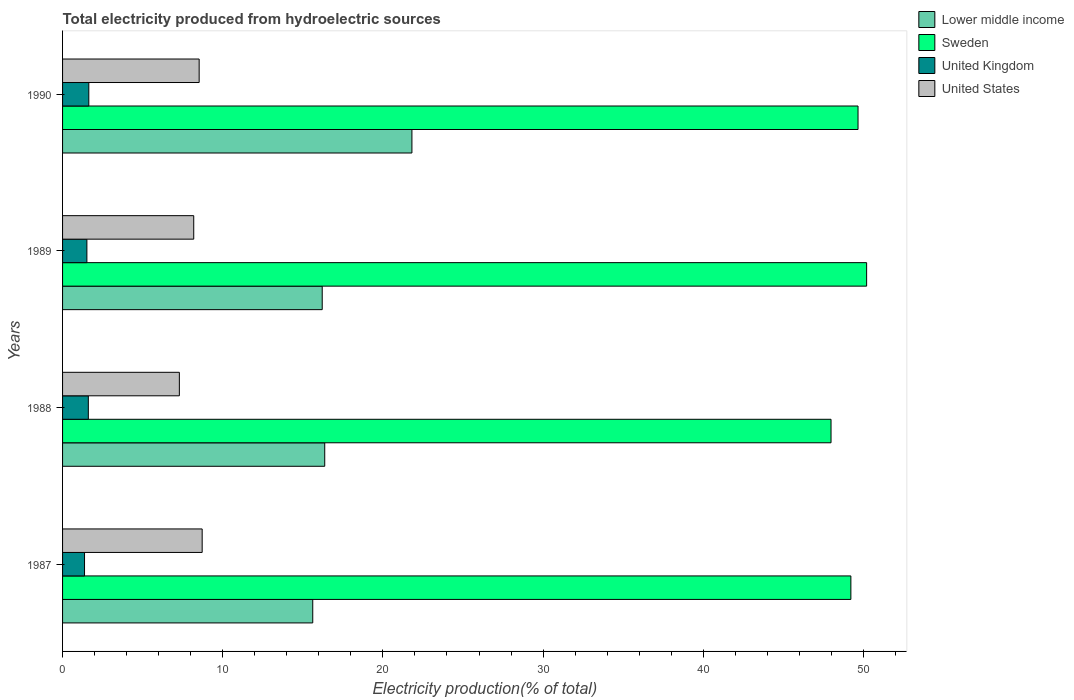How many different coloured bars are there?
Offer a terse response. 4. How many groups of bars are there?
Your answer should be compact. 4. How many bars are there on the 1st tick from the top?
Provide a short and direct response. 4. How many bars are there on the 1st tick from the bottom?
Ensure brevity in your answer.  4. What is the total electricity produced in United Kingdom in 1987?
Ensure brevity in your answer.  1.37. Across all years, what is the maximum total electricity produced in Lower middle income?
Your answer should be very brief. 21.81. Across all years, what is the minimum total electricity produced in United States?
Your response must be concise. 7.29. What is the total total electricity produced in Lower middle income in the graph?
Give a very brief answer. 70.01. What is the difference between the total electricity produced in United Kingdom in 1987 and that in 1990?
Provide a succinct answer. -0.27. What is the difference between the total electricity produced in Sweden in 1987 and the total electricity produced in Lower middle income in 1988?
Your response must be concise. 32.85. What is the average total electricity produced in United States per year?
Your answer should be very brief. 8.18. In the year 1989, what is the difference between the total electricity produced in United Kingdom and total electricity produced in Sweden?
Provide a succinct answer. -48.68. In how many years, is the total electricity produced in United Kingdom greater than 44 %?
Keep it short and to the point. 0. What is the ratio of the total electricity produced in Sweden in 1987 to that in 1989?
Your answer should be compact. 0.98. Is the difference between the total electricity produced in United Kingdom in 1987 and 1989 greater than the difference between the total electricity produced in Sweden in 1987 and 1989?
Offer a very short reply. Yes. What is the difference between the highest and the second highest total electricity produced in Sweden?
Keep it short and to the point. 0.54. What is the difference between the highest and the lowest total electricity produced in United Kingdom?
Your answer should be very brief. 0.27. In how many years, is the total electricity produced in Sweden greater than the average total electricity produced in Sweden taken over all years?
Keep it short and to the point. 2. Is the sum of the total electricity produced in United States in 1987 and 1989 greater than the maximum total electricity produced in Lower middle income across all years?
Your answer should be compact. No. Is it the case that in every year, the sum of the total electricity produced in Sweden and total electricity produced in United States is greater than the sum of total electricity produced in United Kingdom and total electricity produced in Lower middle income?
Provide a short and direct response. No. Is it the case that in every year, the sum of the total electricity produced in United Kingdom and total electricity produced in United States is greater than the total electricity produced in Lower middle income?
Ensure brevity in your answer.  No. How many bars are there?
Your answer should be very brief. 16. Are all the bars in the graph horizontal?
Offer a very short reply. Yes. What is the difference between two consecutive major ticks on the X-axis?
Offer a very short reply. 10. Does the graph contain any zero values?
Offer a very short reply. No. Does the graph contain grids?
Ensure brevity in your answer.  No. Where does the legend appear in the graph?
Your answer should be compact. Top right. What is the title of the graph?
Your answer should be very brief. Total electricity produced from hydroelectric sources. What is the label or title of the X-axis?
Make the answer very short. Electricity production(% of total). What is the Electricity production(% of total) in Lower middle income in 1987?
Ensure brevity in your answer.  15.62. What is the Electricity production(% of total) in Sweden in 1987?
Your answer should be very brief. 49.22. What is the Electricity production(% of total) of United Kingdom in 1987?
Offer a terse response. 1.37. What is the Electricity production(% of total) of United States in 1987?
Ensure brevity in your answer.  8.72. What is the Electricity production(% of total) in Lower middle income in 1988?
Provide a succinct answer. 16.37. What is the Electricity production(% of total) of Sweden in 1988?
Your response must be concise. 47.98. What is the Electricity production(% of total) in United Kingdom in 1988?
Ensure brevity in your answer.  1.61. What is the Electricity production(% of total) in United States in 1988?
Offer a very short reply. 7.29. What is the Electricity production(% of total) in Lower middle income in 1989?
Your answer should be compact. 16.21. What is the Electricity production(% of total) in Sweden in 1989?
Offer a very short reply. 50.2. What is the Electricity production(% of total) in United Kingdom in 1989?
Ensure brevity in your answer.  1.52. What is the Electricity production(% of total) of United States in 1989?
Offer a very short reply. 8.19. What is the Electricity production(% of total) of Lower middle income in 1990?
Your answer should be compact. 21.81. What is the Electricity production(% of total) of Sweden in 1990?
Keep it short and to the point. 49.67. What is the Electricity production(% of total) of United Kingdom in 1990?
Ensure brevity in your answer.  1.64. What is the Electricity production(% of total) of United States in 1990?
Your response must be concise. 8.53. Across all years, what is the maximum Electricity production(% of total) of Lower middle income?
Give a very brief answer. 21.81. Across all years, what is the maximum Electricity production(% of total) in Sweden?
Give a very brief answer. 50.2. Across all years, what is the maximum Electricity production(% of total) in United Kingdom?
Offer a terse response. 1.64. Across all years, what is the maximum Electricity production(% of total) in United States?
Provide a succinct answer. 8.72. Across all years, what is the minimum Electricity production(% of total) of Lower middle income?
Provide a succinct answer. 15.62. Across all years, what is the minimum Electricity production(% of total) in Sweden?
Provide a short and direct response. 47.98. Across all years, what is the minimum Electricity production(% of total) in United Kingdom?
Offer a very short reply. 1.37. Across all years, what is the minimum Electricity production(% of total) of United States?
Keep it short and to the point. 7.29. What is the total Electricity production(% of total) of Lower middle income in the graph?
Offer a very short reply. 70.01. What is the total Electricity production(% of total) in Sweden in the graph?
Make the answer very short. 197.06. What is the total Electricity production(% of total) of United Kingdom in the graph?
Offer a terse response. 6.14. What is the total Electricity production(% of total) of United States in the graph?
Give a very brief answer. 32.73. What is the difference between the Electricity production(% of total) of Lower middle income in 1987 and that in 1988?
Your answer should be compact. -0.75. What is the difference between the Electricity production(% of total) of Sweden in 1987 and that in 1988?
Offer a very short reply. 1.24. What is the difference between the Electricity production(% of total) of United Kingdom in 1987 and that in 1988?
Your response must be concise. -0.24. What is the difference between the Electricity production(% of total) of United States in 1987 and that in 1988?
Offer a very short reply. 1.42. What is the difference between the Electricity production(% of total) in Lower middle income in 1987 and that in 1989?
Give a very brief answer. -0.59. What is the difference between the Electricity production(% of total) of Sweden in 1987 and that in 1989?
Offer a very short reply. -0.98. What is the difference between the Electricity production(% of total) in United Kingdom in 1987 and that in 1989?
Ensure brevity in your answer.  -0.15. What is the difference between the Electricity production(% of total) in United States in 1987 and that in 1989?
Offer a terse response. 0.53. What is the difference between the Electricity production(% of total) of Lower middle income in 1987 and that in 1990?
Ensure brevity in your answer.  -6.19. What is the difference between the Electricity production(% of total) in Sweden in 1987 and that in 1990?
Your answer should be very brief. -0.45. What is the difference between the Electricity production(% of total) of United Kingdom in 1987 and that in 1990?
Your answer should be compact. -0.27. What is the difference between the Electricity production(% of total) of United States in 1987 and that in 1990?
Ensure brevity in your answer.  0.19. What is the difference between the Electricity production(% of total) in Lower middle income in 1988 and that in 1989?
Keep it short and to the point. 0.16. What is the difference between the Electricity production(% of total) in Sweden in 1988 and that in 1989?
Provide a succinct answer. -2.22. What is the difference between the Electricity production(% of total) in United Kingdom in 1988 and that in 1989?
Offer a terse response. 0.09. What is the difference between the Electricity production(% of total) of United States in 1988 and that in 1989?
Ensure brevity in your answer.  -0.9. What is the difference between the Electricity production(% of total) of Lower middle income in 1988 and that in 1990?
Keep it short and to the point. -5.44. What is the difference between the Electricity production(% of total) in Sweden in 1988 and that in 1990?
Offer a terse response. -1.69. What is the difference between the Electricity production(% of total) of United Kingdom in 1988 and that in 1990?
Make the answer very short. -0.03. What is the difference between the Electricity production(% of total) of United States in 1988 and that in 1990?
Offer a very short reply. -1.24. What is the difference between the Electricity production(% of total) in Lower middle income in 1989 and that in 1990?
Offer a terse response. -5.6. What is the difference between the Electricity production(% of total) in Sweden in 1989 and that in 1990?
Offer a terse response. 0.54. What is the difference between the Electricity production(% of total) in United Kingdom in 1989 and that in 1990?
Offer a very short reply. -0.12. What is the difference between the Electricity production(% of total) in United States in 1989 and that in 1990?
Your answer should be compact. -0.34. What is the difference between the Electricity production(% of total) in Lower middle income in 1987 and the Electricity production(% of total) in Sweden in 1988?
Offer a terse response. -32.36. What is the difference between the Electricity production(% of total) of Lower middle income in 1987 and the Electricity production(% of total) of United Kingdom in 1988?
Your answer should be compact. 14.01. What is the difference between the Electricity production(% of total) in Lower middle income in 1987 and the Electricity production(% of total) in United States in 1988?
Provide a succinct answer. 8.33. What is the difference between the Electricity production(% of total) in Sweden in 1987 and the Electricity production(% of total) in United Kingdom in 1988?
Keep it short and to the point. 47.61. What is the difference between the Electricity production(% of total) in Sweden in 1987 and the Electricity production(% of total) in United States in 1988?
Make the answer very short. 41.93. What is the difference between the Electricity production(% of total) in United Kingdom in 1987 and the Electricity production(% of total) in United States in 1988?
Give a very brief answer. -5.92. What is the difference between the Electricity production(% of total) in Lower middle income in 1987 and the Electricity production(% of total) in Sweden in 1989?
Make the answer very short. -34.58. What is the difference between the Electricity production(% of total) of Lower middle income in 1987 and the Electricity production(% of total) of United Kingdom in 1989?
Offer a very short reply. 14.1. What is the difference between the Electricity production(% of total) in Lower middle income in 1987 and the Electricity production(% of total) in United States in 1989?
Ensure brevity in your answer.  7.43. What is the difference between the Electricity production(% of total) in Sweden in 1987 and the Electricity production(% of total) in United Kingdom in 1989?
Offer a very short reply. 47.7. What is the difference between the Electricity production(% of total) in Sweden in 1987 and the Electricity production(% of total) in United States in 1989?
Keep it short and to the point. 41.03. What is the difference between the Electricity production(% of total) in United Kingdom in 1987 and the Electricity production(% of total) in United States in 1989?
Your answer should be compact. -6.82. What is the difference between the Electricity production(% of total) of Lower middle income in 1987 and the Electricity production(% of total) of Sweden in 1990?
Your response must be concise. -34.05. What is the difference between the Electricity production(% of total) of Lower middle income in 1987 and the Electricity production(% of total) of United Kingdom in 1990?
Give a very brief answer. 13.98. What is the difference between the Electricity production(% of total) in Lower middle income in 1987 and the Electricity production(% of total) in United States in 1990?
Your response must be concise. 7.09. What is the difference between the Electricity production(% of total) of Sweden in 1987 and the Electricity production(% of total) of United Kingdom in 1990?
Your answer should be compact. 47.58. What is the difference between the Electricity production(% of total) in Sweden in 1987 and the Electricity production(% of total) in United States in 1990?
Your answer should be compact. 40.69. What is the difference between the Electricity production(% of total) of United Kingdom in 1987 and the Electricity production(% of total) of United States in 1990?
Provide a short and direct response. -7.16. What is the difference between the Electricity production(% of total) in Lower middle income in 1988 and the Electricity production(% of total) in Sweden in 1989?
Your response must be concise. -33.83. What is the difference between the Electricity production(% of total) of Lower middle income in 1988 and the Electricity production(% of total) of United Kingdom in 1989?
Keep it short and to the point. 14.85. What is the difference between the Electricity production(% of total) in Lower middle income in 1988 and the Electricity production(% of total) in United States in 1989?
Offer a very short reply. 8.18. What is the difference between the Electricity production(% of total) in Sweden in 1988 and the Electricity production(% of total) in United Kingdom in 1989?
Keep it short and to the point. 46.46. What is the difference between the Electricity production(% of total) in Sweden in 1988 and the Electricity production(% of total) in United States in 1989?
Your answer should be very brief. 39.79. What is the difference between the Electricity production(% of total) in United Kingdom in 1988 and the Electricity production(% of total) in United States in 1989?
Offer a terse response. -6.58. What is the difference between the Electricity production(% of total) in Lower middle income in 1988 and the Electricity production(% of total) in Sweden in 1990?
Your response must be concise. -33.3. What is the difference between the Electricity production(% of total) in Lower middle income in 1988 and the Electricity production(% of total) in United Kingdom in 1990?
Provide a succinct answer. 14.73. What is the difference between the Electricity production(% of total) in Lower middle income in 1988 and the Electricity production(% of total) in United States in 1990?
Ensure brevity in your answer.  7.84. What is the difference between the Electricity production(% of total) in Sweden in 1988 and the Electricity production(% of total) in United Kingdom in 1990?
Your answer should be very brief. 46.34. What is the difference between the Electricity production(% of total) of Sweden in 1988 and the Electricity production(% of total) of United States in 1990?
Your answer should be very brief. 39.45. What is the difference between the Electricity production(% of total) of United Kingdom in 1988 and the Electricity production(% of total) of United States in 1990?
Your answer should be very brief. -6.92. What is the difference between the Electricity production(% of total) in Lower middle income in 1989 and the Electricity production(% of total) in Sweden in 1990?
Provide a short and direct response. -33.45. What is the difference between the Electricity production(% of total) in Lower middle income in 1989 and the Electricity production(% of total) in United Kingdom in 1990?
Make the answer very short. 14.57. What is the difference between the Electricity production(% of total) of Lower middle income in 1989 and the Electricity production(% of total) of United States in 1990?
Provide a succinct answer. 7.68. What is the difference between the Electricity production(% of total) of Sweden in 1989 and the Electricity production(% of total) of United Kingdom in 1990?
Your response must be concise. 48.56. What is the difference between the Electricity production(% of total) of Sweden in 1989 and the Electricity production(% of total) of United States in 1990?
Offer a very short reply. 41.67. What is the difference between the Electricity production(% of total) in United Kingdom in 1989 and the Electricity production(% of total) in United States in 1990?
Offer a terse response. -7.01. What is the average Electricity production(% of total) of Lower middle income per year?
Make the answer very short. 17.5. What is the average Electricity production(% of total) of Sweden per year?
Ensure brevity in your answer.  49.27. What is the average Electricity production(% of total) of United Kingdom per year?
Keep it short and to the point. 1.53. What is the average Electricity production(% of total) in United States per year?
Your answer should be compact. 8.18. In the year 1987, what is the difference between the Electricity production(% of total) in Lower middle income and Electricity production(% of total) in Sweden?
Offer a terse response. -33.6. In the year 1987, what is the difference between the Electricity production(% of total) of Lower middle income and Electricity production(% of total) of United Kingdom?
Provide a short and direct response. 14.25. In the year 1987, what is the difference between the Electricity production(% of total) of Lower middle income and Electricity production(% of total) of United States?
Offer a terse response. 6.9. In the year 1987, what is the difference between the Electricity production(% of total) in Sweden and Electricity production(% of total) in United Kingdom?
Your answer should be very brief. 47.85. In the year 1987, what is the difference between the Electricity production(% of total) in Sweden and Electricity production(% of total) in United States?
Make the answer very short. 40.5. In the year 1987, what is the difference between the Electricity production(% of total) of United Kingdom and Electricity production(% of total) of United States?
Keep it short and to the point. -7.35. In the year 1988, what is the difference between the Electricity production(% of total) of Lower middle income and Electricity production(% of total) of Sweden?
Your response must be concise. -31.61. In the year 1988, what is the difference between the Electricity production(% of total) in Lower middle income and Electricity production(% of total) in United Kingdom?
Make the answer very short. 14.76. In the year 1988, what is the difference between the Electricity production(% of total) in Lower middle income and Electricity production(% of total) in United States?
Ensure brevity in your answer.  9.08. In the year 1988, what is the difference between the Electricity production(% of total) of Sweden and Electricity production(% of total) of United Kingdom?
Your answer should be very brief. 46.37. In the year 1988, what is the difference between the Electricity production(% of total) of Sweden and Electricity production(% of total) of United States?
Provide a succinct answer. 40.69. In the year 1988, what is the difference between the Electricity production(% of total) of United Kingdom and Electricity production(% of total) of United States?
Give a very brief answer. -5.68. In the year 1989, what is the difference between the Electricity production(% of total) of Lower middle income and Electricity production(% of total) of Sweden?
Provide a succinct answer. -33.99. In the year 1989, what is the difference between the Electricity production(% of total) of Lower middle income and Electricity production(% of total) of United Kingdom?
Your response must be concise. 14.69. In the year 1989, what is the difference between the Electricity production(% of total) in Lower middle income and Electricity production(% of total) in United States?
Make the answer very short. 8.02. In the year 1989, what is the difference between the Electricity production(% of total) of Sweden and Electricity production(% of total) of United Kingdom?
Provide a succinct answer. 48.68. In the year 1989, what is the difference between the Electricity production(% of total) in Sweden and Electricity production(% of total) in United States?
Offer a terse response. 42.01. In the year 1989, what is the difference between the Electricity production(% of total) in United Kingdom and Electricity production(% of total) in United States?
Ensure brevity in your answer.  -6.67. In the year 1990, what is the difference between the Electricity production(% of total) of Lower middle income and Electricity production(% of total) of Sweden?
Provide a short and direct response. -27.85. In the year 1990, what is the difference between the Electricity production(% of total) of Lower middle income and Electricity production(% of total) of United Kingdom?
Your answer should be very brief. 20.17. In the year 1990, what is the difference between the Electricity production(% of total) in Lower middle income and Electricity production(% of total) in United States?
Provide a succinct answer. 13.28. In the year 1990, what is the difference between the Electricity production(% of total) of Sweden and Electricity production(% of total) of United Kingdom?
Your answer should be very brief. 48.03. In the year 1990, what is the difference between the Electricity production(% of total) in Sweden and Electricity production(% of total) in United States?
Make the answer very short. 41.14. In the year 1990, what is the difference between the Electricity production(% of total) in United Kingdom and Electricity production(% of total) in United States?
Your answer should be compact. -6.89. What is the ratio of the Electricity production(% of total) of Lower middle income in 1987 to that in 1988?
Offer a very short reply. 0.95. What is the ratio of the Electricity production(% of total) of Sweden in 1987 to that in 1988?
Offer a terse response. 1.03. What is the ratio of the Electricity production(% of total) in United Kingdom in 1987 to that in 1988?
Offer a very short reply. 0.85. What is the ratio of the Electricity production(% of total) in United States in 1987 to that in 1988?
Your answer should be very brief. 1.2. What is the ratio of the Electricity production(% of total) of Lower middle income in 1987 to that in 1989?
Your answer should be very brief. 0.96. What is the ratio of the Electricity production(% of total) of Sweden in 1987 to that in 1989?
Offer a terse response. 0.98. What is the ratio of the Electricity production(% of total) in United Kingdom in 1987 to that in 1989?
Offer a terse response. 0.9. What is the ratio of the Electricity production(% of total) in United States in 1987 to that in 1989?
Ensure brevity in your answer.  1.06. What is the ratio of the Electricity production(% of total) in Lower middle income in 1987 to that in 1990?
Your response must be concise. 0.72. What is the ratio of the Electricity production(% of total) of Sweden in 1987 to that in 1990?
Your response must be concise. 0.99. What is the ratio of the Electricity production(% of total) of United Kingdom in 1987 to that in 1990?
Ensure brevity in your answer.  0.84. What is the ratio of the Electricity production(% of total) of United States in 1987 to that in 1990?
Your response must be concise. 1.02. What is the ratio of the Electricity production(% of total) in Lower middle income in 1988 to that in 1989?
Keep it short and to the point. 1.01. What is the ratio of the Electricity production(% of total) of Sweden in 1988 to that in 1989?
Give a very brief answer. 0.96. What is the ratio of the Electricity production(% of total) of United Kingdom in 1988 to that in 1989?
Provide a succinct answer. 1.06. What is the ratio of the Electricity production(% of total) in United States in 1988 to that in 1989?
Your response must be concise. 0.89. What is the ratio of the Electricity production(% of total) in Lower middle income in 1988 to that in 1990?
Ensure brevity in your answer.  0.75. What is the ratio of the Electricity production(% of total) of Sweden in 1988 to that in 1990?
Provide a succinct answer. 0.97. What is the ratio of the Electricity production(% of total) of United Kingdom in 1988 to that in 1990?
Give a very brief answer. 0.98. What is the ratio of the Electricity production(% of total) in United States in 1988 to that in 1990?
Keep it short and to the point. 0.85. What is the ratio of the Electricity production(% of total) of Lower middle income in 1989 to that in 1990?
Give a very brief answer. 0.74. What is the ratio of the Electricity production(% of total) of Sweden in 1989 to that in 1990?
Your answer should be compact. 1.01. What is the ratio of the Electricity production(% of total) of United Kingdom in 1989 to that in 1990?
Your answer should be compact. 0.93. What is the ratio of the Electricity production(% of total) of United States in 1989 to that in 1990?
Keep it short and to the point. 0.96. What is the difference between the highest and the second highest Electricity production(% of total) in Lower middle income?
Your answer should be compact. 5.44. What is the difference between the highest and the second highest Electricity production(% of total) in Sweden?
Provide a short and direct response. 0.54. What is the difference between the highest and the second highest Electricity production(% of total) of United Kingdom?
Provide a succinct answer. 0.03. What is the difference between the highest and the second highest Electricity production(% of total) of United States?
Offer a terse response. 0.19. What is the difference between the highest and the lowest Electricity production(% of total) in Lower middle income?
Your answer should be very brief. 6.19. What is the difference between the highest and the lowest Electricity production(% of total) in Sweden?
Offer a terse response. 2.22. What is the difference between the highest and the lowest Electricity production(% of total) in United Kingdom?
Make the answer very short. 0.27. What is the difference between the highest and the lowest Electricity production(% of total) of United States?
Provide a succinct answer. 1.42. 